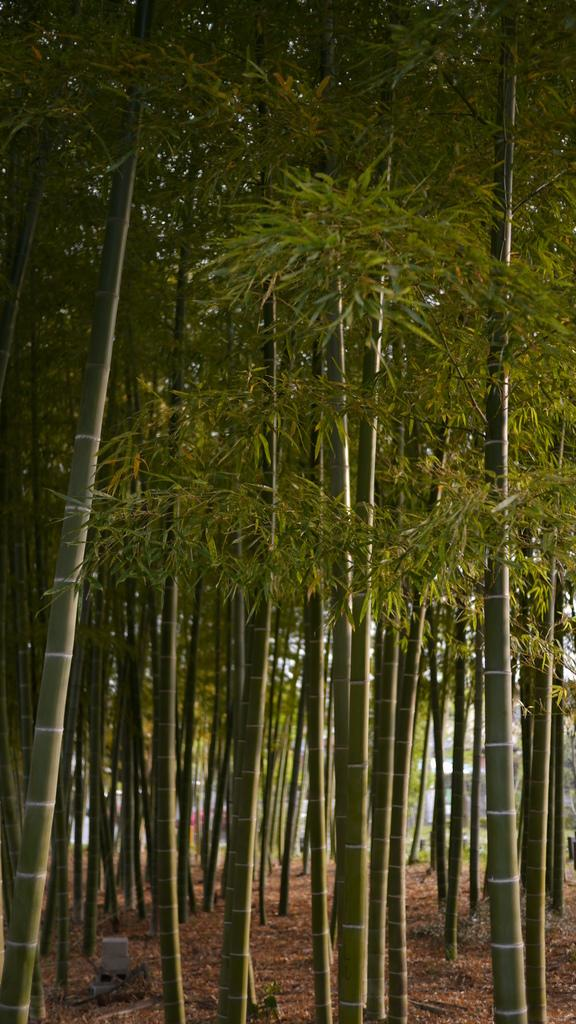What type of vegetation is present in the image? There are bamboo trees with leaves in the image. Can you describe the object placed on the ground in the image? Unfortunately, the facts provided do not give any details about the object placed on the ground. What is the price of the bikes in the image? There are no bikes present in the image, so it is not possible to determine the price of any bikes. 